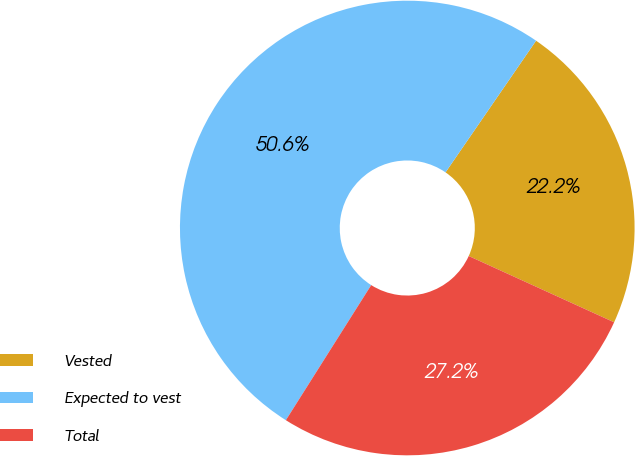<chart> <loc_0><loc_0><loc_500><loc_500><pie_chart><fcel>Vested<fcel>Expected to vest<fcel>Total<nl><fcel>22.22%<fcel>50.62%<fcel>27.16%<nl></chart> 